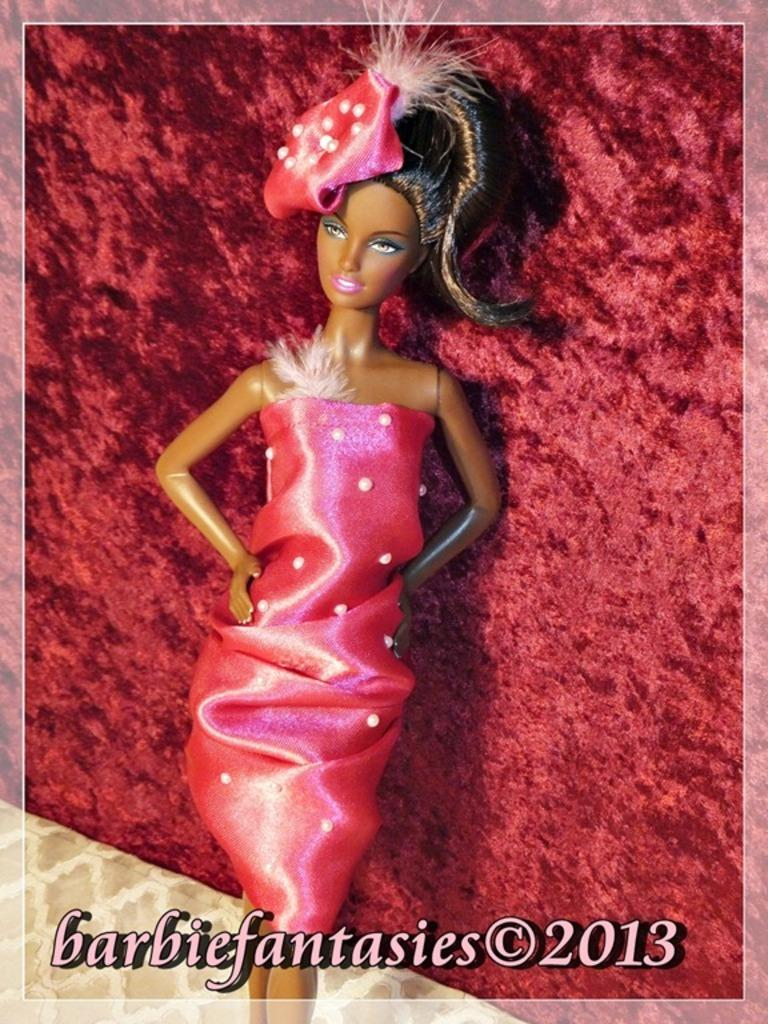What is the main subject of the image? There is a Barbie doll in the image. What color is the background of the image? The background of the image is red. Is there any text present in the image? Yes, there is some text at the bottom of the image. Can you tell me how many horns are on the Barbie doll in the image? There are no horns present on the Barbie doll in the image. What type of bomb can be seen in the image? There is no bomb present in the image; it features a Barbie doll and a red background. 